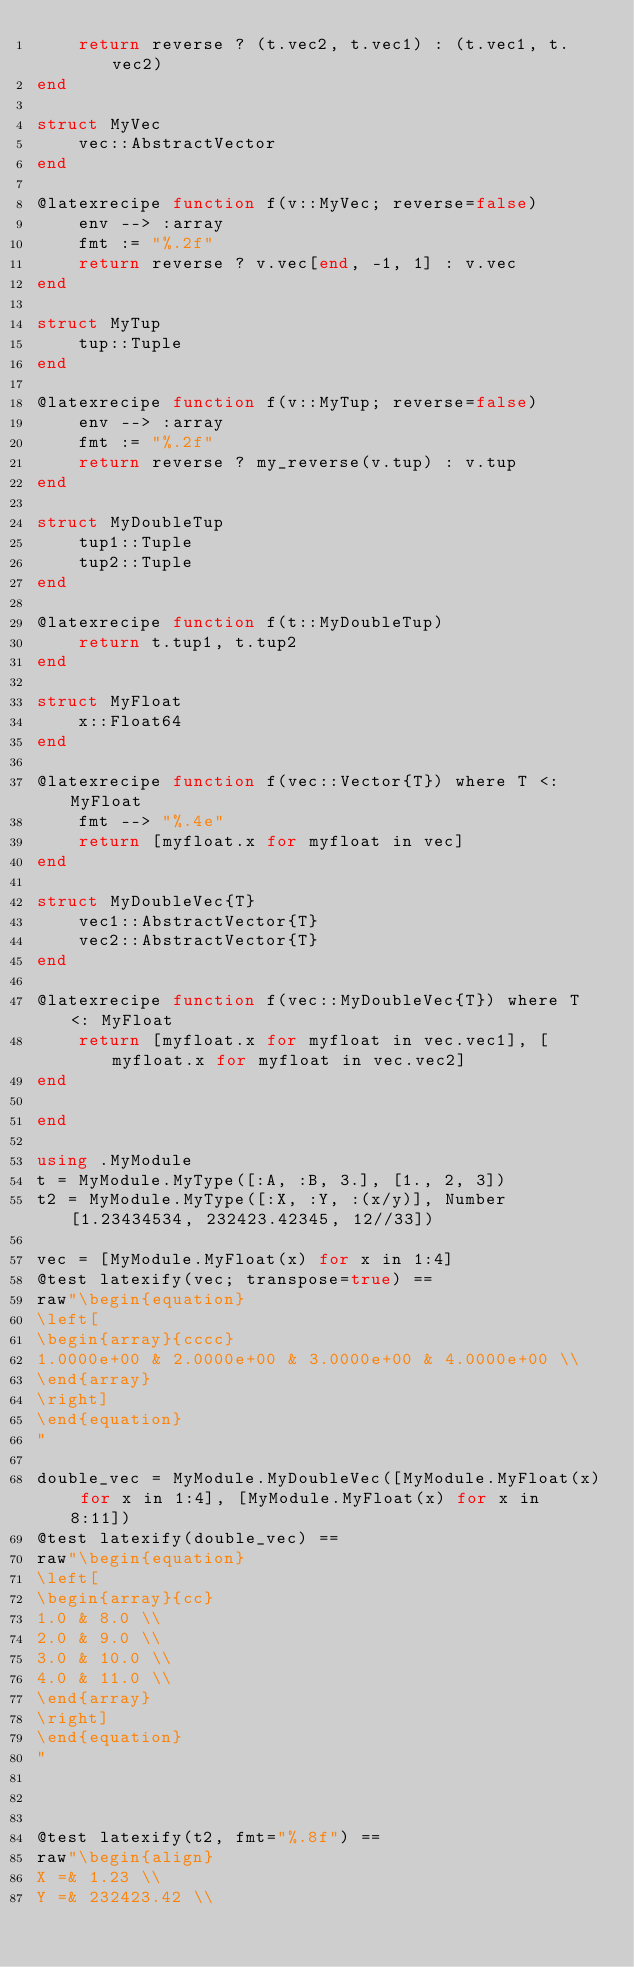Convert code to text. <code><loc_0><loc_0><loc_500><loc_500><_Julia_>    return reverse ? (t.vec2, t.vec1) : (t.vec1, t.vec2)
end

struct MyVec
    vec::AbstractVector
end

@latexrecipe function f(v::MyVec; reverse=false)
    env --> :array
    fmt := "%.2f"
    return reverse ? v.vec[end, -1, 1] : v.vec
end

struct MyTup
    tup::Tuple
end

@latexrecipe function f(v::MyTup; reverse=false)
    env --> :array
    fmt := "%.2f"
    return reverse ? my_reverse(v.tup) : v.tup
end

struct MyDoubleTup
    tup1::Tuple
    tup2::Tuple
end

@latexrecipe function f(t::MyDoubleTup)
    return t.tup1, t.tup2
end

struct MyFloat 
    x::Float64
end

@latexrecipe function f(vec::Vector{T}) where T <: MyFloat
    fmt --> "%.4e"
    return [myfloat.x for myfloat in vec]
end

struct MyDoubleVec{T}
    vec1::AbstractVector{T}
    vec2::AbstractVector{T}
end

@latexrecipe function f(vec::MyDoubleVec{T}) where T <: MyFloat
    return [myfloat.x for myfloat in vec.vec1], [myfloat.x for myfloat in vec.vec2]
end

end

using .MyModule
t = MyModule.MyType([:A, :B, 3.], [1., 2, 3])
t2 = MyModule.MyType([:X, :Y, :(x/y)], Number[1.23434534, 232423.42345, 12//33])

vec = [MyModule.MyFloat(x) for x in 1:4]
@test latexify(vec; transpose=true) == 
raw"\begin{equation}
\left[
\begin{array}{cccc}
1.0000e+00 & 2.0000e+00 & 3.0000e+00 & 4.0000e+00 \\
\end{array}
\right]
\end{equation}
"

double_vec = MyModule.MyDoubleVec([MyModule.MyFloat(x) for x in 1:4], [MyModule.MyFloat(x) for x in 8:11])
@test latexify(double_vec) == 
raw"\begin{equation}
\left[
\begin{array}{cc}
1.0 & 8.0 \\
2.0 & 9.0 \\
3.0 & 10.0 \\
4.0 & 11.0 \\
\end{array}
\right]
\end{equation}
"



@test latexify(t2, fmt="%.8f") == 
raw"\begin{align}
X =& 1.23 \\
Y =& 232423.42 \\</code> 